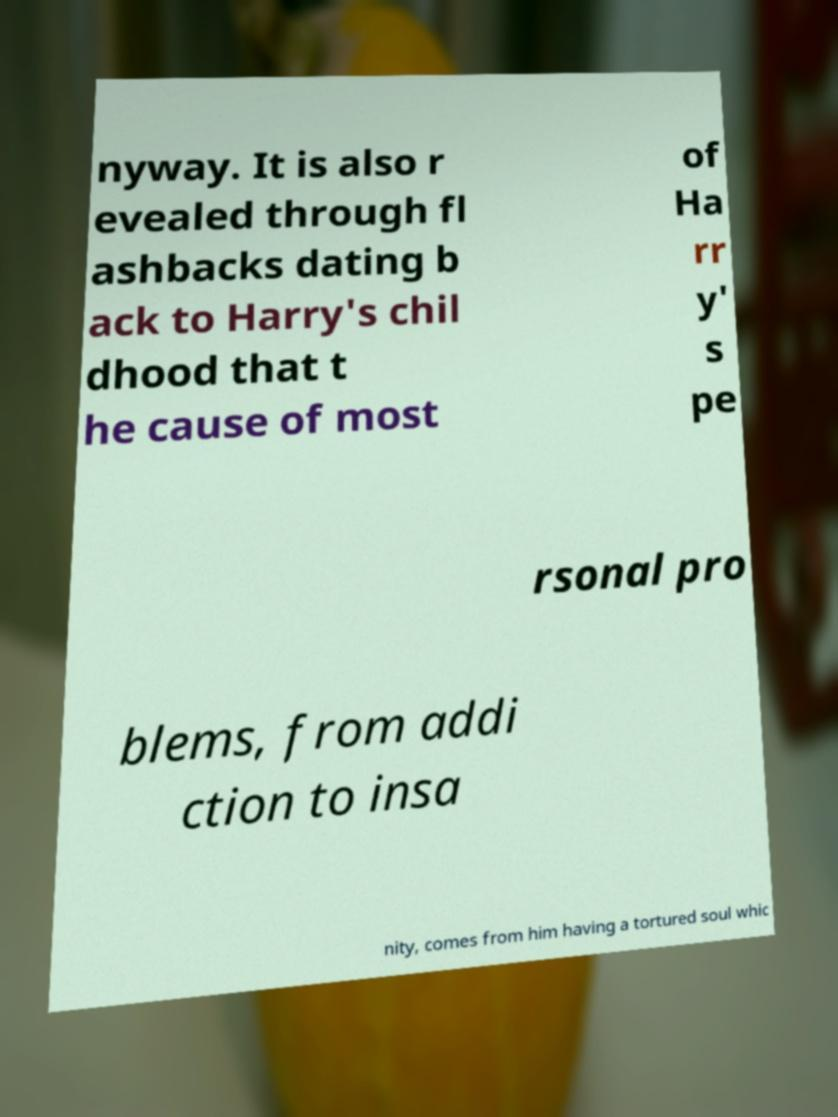Can you accurately transcribe the text from the provided image for me? nyway. It is also r evealed through fl ashbacks dating b ack to Harry's chil dhood that t he cause of most of Ha rr y' s pe rsonal pro blems, from addi ction to insa nity, comes from him having a tortured soul whic 